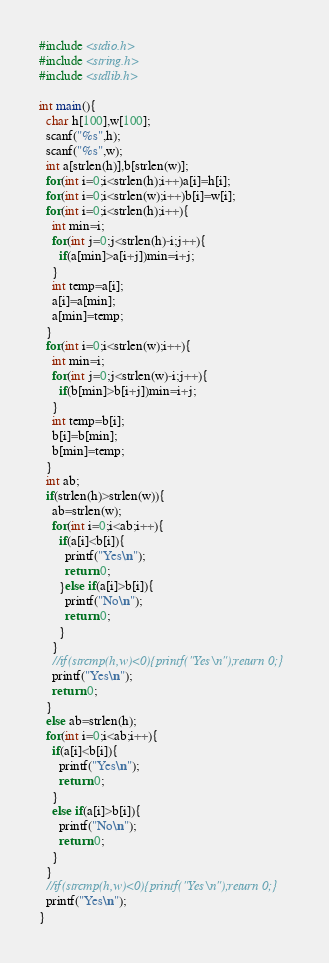Convert code to text. <code><loc_0><loc_0><loc_500><loc_500><_C_>#include <stdio.h>
#include <string.h>
#include <stdlib.h>

int main(){
  char h[100],w[100];
  scanf("%s",h);
  scanf("%s",w);
  int a[strlen(h)],b[strlen(w)];
  for(int i=0;i<strlen(h);i++)a[i]=h[i];
  for(int i=0;i<strlen(w);i++)b[i]=w[i];
  for(int i=0;i<strlen(h);i++){
    int min=i;
    for(int j=0;j<strlen(h)-i;j++){
      if(a[min]>a[i+j])min=i+j;
    }
    int temp=a[i];
    a[i]=a[min];
    a[min]=temp;
  }
  for(int i=0;i<strlen(w);i++){
    int min=i;
    for(int j=0;j<strlen(w)-i;j++){
      if(b[min]>b[i+j])min=i+j;
    }
    int temp=b[i];
    b[i]=b[min];
    b[min]=temp;
  }
  int ab;
  if(strlen(h)>strlen(w)){
    ab=strlen(w);
    for(int i=0;i<ab;i++){
      if(a[i]<b[i]){
        printf("Yes\n");
        return 0;
      }else if(a[i]>b[i]){
        printf("No\n");
        return 0;
      }
    }
    //if(strcmp(h,w)<0){printf("Yes\n");return 0;}
    printf("Yes\n");
    return 0;
  }
  else ab=strlen(h);
  for(int i=0;i<ab;i++){
    if(a[i]<b[i]){
      printf("Yes\n");
      return 0;
    }
    else if(a[i]>b[i]){
      printf("No\n");
      return 0;
    }
  }
  //if(strcmp(h,w)<0){printf("Yes\n");return 0;}
  printf("Yes\n");
}
</code> 